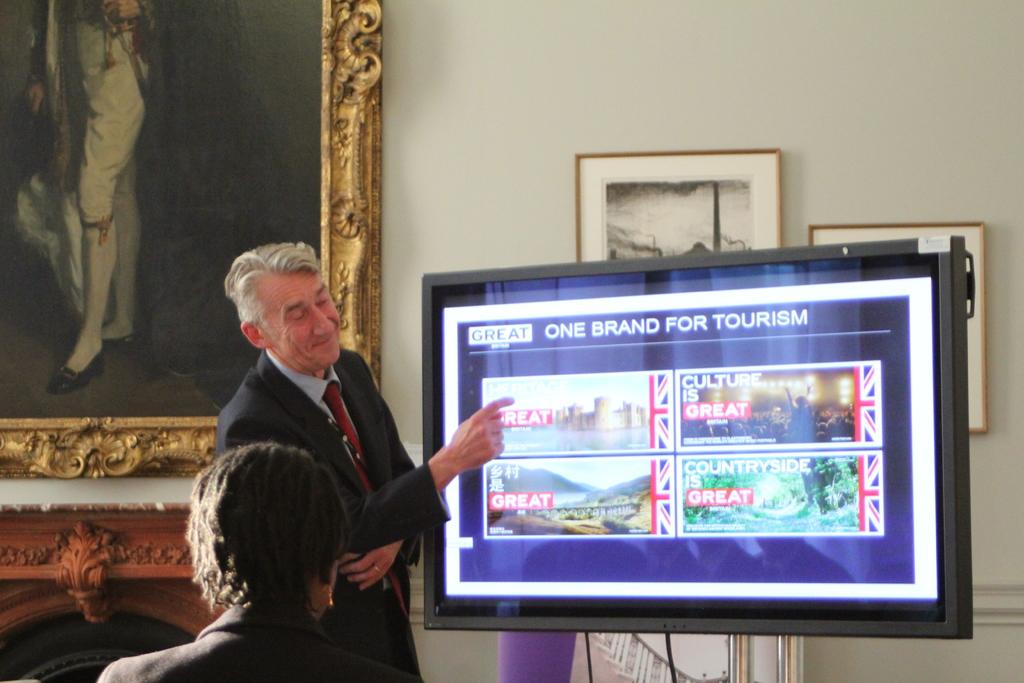What is the man standing beside in the image? The man is standing beside a television. What is displayed on the television screen? The television screen contains text and pictures. Can you describe another person in the image? There is a woman in the image. What can be seen on the wall in the image? There are photo frames on a wall. How many spiders are crawling on the television screen in the image? There are no spiders present on the television screen in the image. What is the woman learning from the television screen in the image? The facts provided do not indicate what the woman is learning from the television screen. What type of cord is connected to the television in the image? The facts provided do not mention any cords connected to the television in the image. 